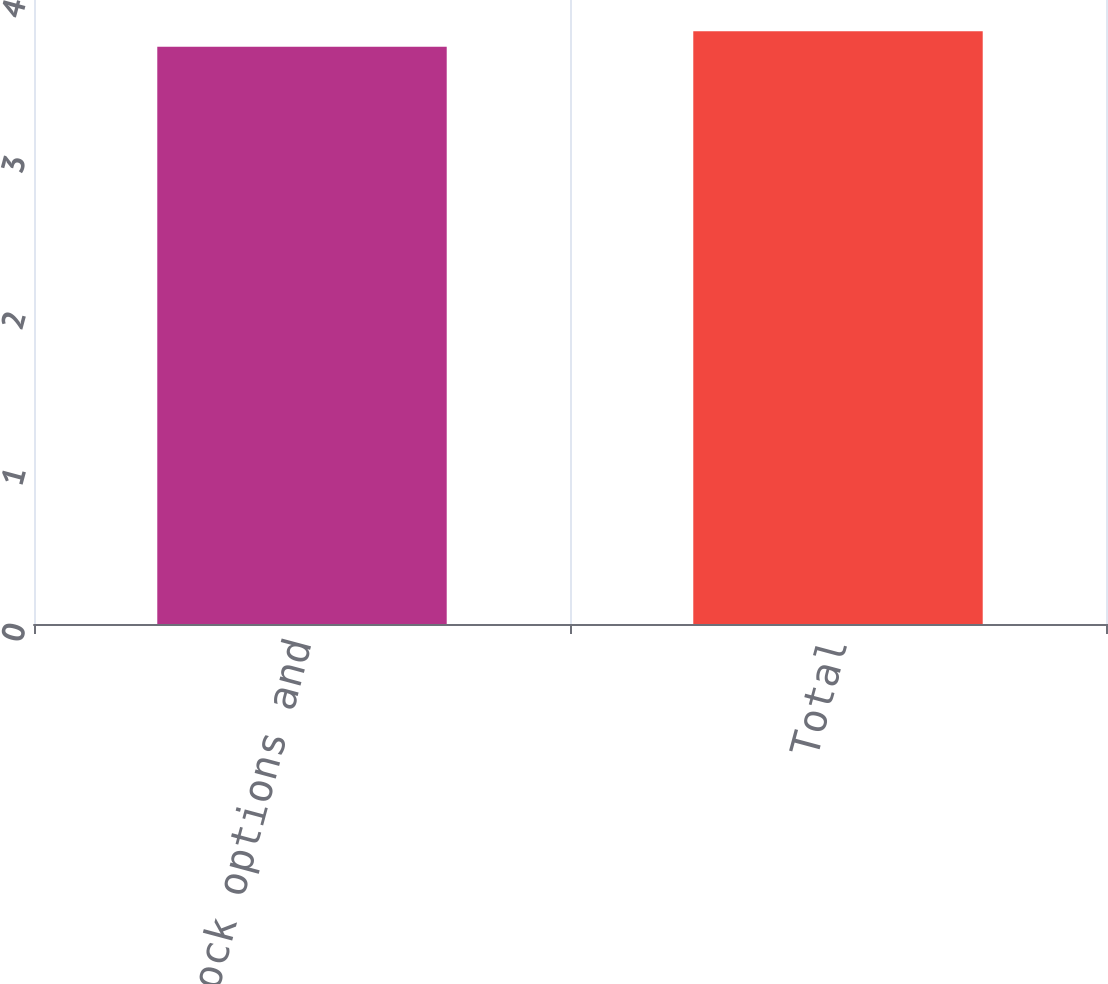Convert chart to OTSL. <chart><loc_0><loc_0><loc_500><loc_500><bar_chart><fcel>Other stock options and<fcel>Total<nl><fcel>3.7<fcel>3.8<nl></chart> 